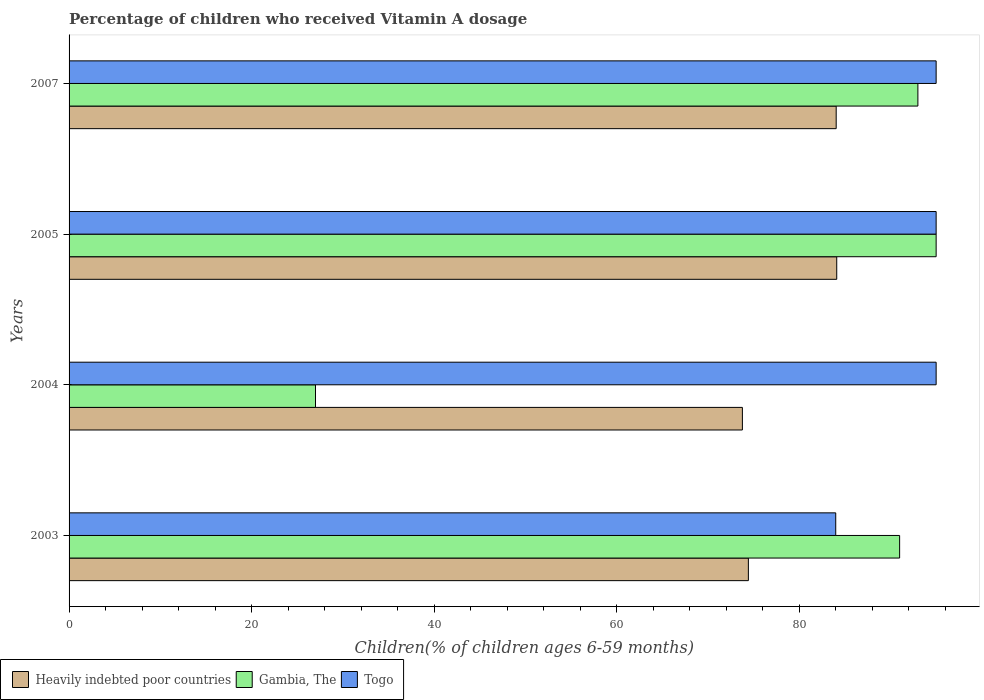Are the number of bars on each tick of the Y-axis equal?
Provide a short and direct response. Yes. How many bars are there on the 2nd tick from the top?
Offer a very short reply. 3. How many bars are there on the 2nd tick from the bottom?
Keep it short and to the point. 3. Across all years, what is the maximum percentage of children who received Vitamin A dosage in Heavily indebted poor countries?
Ensure brevity in your answer.  84.11. In which year was the percentage of children who received Vitamin A dosage in Togo minimum?
Provide a short and direct response. 2003. What is the total percentage of children who received Vitamin A dosage in Togo in the graph?
Provide a succinct answer. 369. What is the difference between the percentage of children who received Vitamin A dosage in Gambia, The in 2003 and that in 2007?
Provide a succinct answer. -2. What is the difference between the percentage of children who received Vitamin A dosage in Heavily indebted poor countries in 2004 and the percentage of children who received Vitamin A dosage in Togo in 2007?
Your answer should be very brief. -21.23. What is the average percentage of children who received Vitamin A dosage in Gambia, The per year?
Your response must be concise. 76.5. In the year 2004, what is the difference between the percentage of children who received Vitamin A dosage in Heavily indebted poor countries and percentage of children who received Vitamin A dosage in Togo?
Your answer should be very brief. -21.23. In how many years, is the percentage of children who received Vitamin A dosage in Gambia, The greater than 32 %?
Keep it short and to the point. 3. What is the ratio of the percentage of children who received Vitamin A dosage in Heavily indebted poor countries in 2003 to that in 2005?
Make the answer very short. 0.88. Is the percentage of children who received Vitamin A dosage in Heavily indebted poor countries in 2003 less than that in 2007?
Offer a very short reply. Yes. What is the difference between the highest and the second highest percentage of children who received Vitamin A dosage in Heavily indebted poor countries?
Make the answer very short. 0.06. In how many years, is the percentage of children who received Vitamin A dosage in Heavily indebted poor countries greater than the average percentage of children who received Vitamin A dosage in Heavily indebted poor countries taken over all years?
Make the answer very short. 2. What does the 2nd bar from the top in 2003 represents?
Your answer should be very brief. Gambia, The. What does the 1st bar from the bottom in 2003 represents?
Your answer should be compact. Heavily indebted poor countries. Is it the case that in every year, the sum of the percentage of children who received Vitamin A dosage in Heavily indebted poor countries and percentage of children who received Vitamin A dosage in Togo is greater than the percentage of children who received Vitamin A dosage in Gambia, The?
Make the answer very short. Yes. Are all the bars in the graph horizontal?
Your answer should be compact. Yes. What is the difference between two consecutive major ticks on the X-axis?
Offer a terse response. 20. Are the values on the major ticks of X-axis written in scientific E-notation?
Make the answer very short. No. Where does the legend appear in the graph?
Give a very brief answer. Bottom left. How many legend labels are there?
Offer a very short reply. 3. How are the legend labels stacked?
Your answer should be compact. Horizontal. What is the title of the graph?
Ensure brevity in your answer.  Percentage of children who received Vitamin A dosage. Does "Cabo Verde" appear as one of the legend labels in the graph?
Provide a short and direct response. No. What is the label or title of the X-axis?
Offer a very short reply. Children(% of children ages 6-59 months). What is the Children(% of children ages 6-59 months) of Heavily indebted poor countries in 2003?
Your answer should be very brief. 74.43. What is the Children(% of children ages 6-59 months) in Gambia, The in 2003?
Keep it short and to the point. 91. What is the Children(% of children ages 6-59 months) in Togo in 2003?
Your answer should be very brief. 84. What is the Children(% of children ages 6-59 months) in Heavily indebted poor countries in 2004?
Keep it short and to the point. 73.77. What is the Children(% of children ages 6-59 months) in Heavily indebted poor countries in 2005?
Keep it short and to the point. 84.11. What is the Children(% of children ages 6-59 months) in Heavily indebted poor countries in 2007?
Give a very brief answer. 84.05. What is the Children(% of children ages 6-59 months) of Gambia, The in 2007?
Offer a terse response. 93. What is the Children(% of children ages 6-59 months) of Togo in 2007?
Provide a short and direct response. 95. Across all years, what is the maximum Children(% of children ages 6-59 months) in Heavily indebted poor countries?
Give a very brief answer. 84.11. Across all years, what is the maximum Children(% of children ages 6-59 months) of Gambia, The?
Ensure brevity in your answer.  95. Across all years, what is the maximum Children(% of children ages 6-59 months) in Togo?
Your response must be concise. 95. Across all years, what is the minimum Children(% of children ages 6-59 months) of Heavily indebted poor countries?
Make the answer very short. 73.77. Across all years, what is the minimum Children(% of children ages 6-59 months) of Gambia, The?
Your answer should be very brief. 27. What is the total Children(% of children ages 6-59 months) of Heavily indebted poor countries in the graph?
Ensure brevity in your answer.  316.36. What is the total Children(% of children ages 6-59 months) of Gambia, The in the graph?
Provide a succinct answer. 306. What is the total Children(% of children ages 6-59 months) of Togo in the graph?
Make the answer very short. 369. What is the difference between the Children(% of children ages 6-59 months) in Heavily indebted poor countries in 2003 and that in 2004?
Give a very brief answer. 0.66. What is the difference between the Children(% of children ages 6-59 months) of Togo in 2003 and that in 2004?
Your answer should be very brief. -11. What is the difference between the Children(% of children ages 6-59 months) of Heavily indebted poor countries in 2003 and that in 2005?
Keep it short and to the point. -9.68. What is the difference between the Children(% of children ages 6-59 months) in Togo in 2003 and that in 2005?
Your answer should be compact. -11. What is the difference between the Children(% of children ages 6-59 months) in Heavily indebted poor countries in 2003 and that in 2007?
Give a very brief answer. -9.62. What is the difference between the Children(% of children ages 6-59 months) in Heavily indebted poor countries in 2004 and that in 2005?
Your answer should be compact. -10.34. What is the difference between the Children(% of children ages 6-59 months) in Gambia, The in 2004 and that in 2005?
Provide a short and direct response. -68. What is the difference between the Children(% of children ages 6-59 months) of Heavily indebted poor countries in 2004 and that in 2007?
Provide a short and direct response. -10.28. What is the difference between the Children(% of children ages 6-59 months) in Gambia, The in 2004 and that in 2007?
Your answer should be very brief. -66. What is the difference between the Children(% of children ages 6-59 months) of Heavily indebted poor countries in 2005 and that in 2007?
Make the answer very short. 0.06. What is the difference between the Children(% of children ages 6-59 months) in Togo in 2005 and that in 2007?
Your answer should be compact. 0. What is the difference between the Children(% of children ages 6-59 months) in Heavily indebted poor countries in 2003 and the Children(% of children ages 6-59 months) in Gambia, The in 2004?
Provide a succinct answer. 47.43. What is the difference between the Children(% of children ages 6-59 months) in Heavily indebted poor countries in 2003 and the Children(% of children ages 6-59 months) in Togo in 2004?
Your response must be concise. -20.57. What is the difference between the Children(% of children ages 6-59 months) of Heavily indebted poor countries in 2003 and the Children(% of children ages 6-59 months) of Gambia, The in 2005?
Offer a very short reply. -20.57. What is the difference between the Children(% of children ages 6-59 months) in Heavily indebted poor countries in 2003 and the Children(% of children ages 6-59 months) in Togo in 2005?
Provide a succinct answer. -20.57. What is the difference between the Children(% of children ages 6-59 months) in Gambia, The in 2003 and the Children(% of children ages 6-59 months) in Togo in 2005?
Provide a short and direct response. -4. What is the difference between the Children(% of children ages 6-59 months) in Heavily indebted poor countries in 2003 and the Children(% of children ages 6-59 months) in Gambia, The in 2007?
Offer a very short reply. -18.57. What is the difference between the Children(% of children ages 6-59 months) of Heavily indebted poor countries in 2003 and the Children(% of children ages 6-59 months) of Togo in 2007?
Provide a short and direct response. -20.57. What is the difference between the Children(% of children ages 6-59 months) in Heavily indebted poor countries in 2004 and the Children(% of children ages 6-59 months) in Gambia, The in 2005?
Provide a succinct answer. -21.23. What is the difference between the Children(% of children ages 6-59 months) in Heavily indebted poor countries in 2004 and the Children(% of children ages 6-59 months) in Togo in 2005?
Offer a terse response. -21.23. What is the difference between the Children(% of children ages 6-59 months) of Gambia, The in 2004 and the Children(% of children ages 6-59 months) of Togo in 2005?
Offer a very short reply. -68. What is the difference between the Children(% of children ages 6-59 months) in Heavily indebted poor countries in 2004 and the Children(% of children ages 6-59 months) in Gambia, The in 2007?
Provide a short and direct response. -19.23. What is the difference between the Children(% of children ages 6-59 months) in Heavily indebted poor countries in 2004 and the Children(% of children ages 6-59 months) in Togo in 2007?
Provide a short and direct response. -21.23. What is the difference between the Children(% of children ages 6-59 months) of Gambia, The in 2004 and the Children(% of children ages 6-59 months) of Togo in 2007?
Provide a succinct answer. -68. What is the difference between the Children(% of children ages 6-59 months) of Heavily indebted poor countries in 2005 and the Children(% of children ages 6-59 months) of Gambia, The in 2007?
Your response must be concise. -8.89. What is the difference between the Children(% of children ages 6-59 months) in Heavily indebted poor countries in 2005 and the Children(% of children ages 6-59 months) in Togo in 2007?
Provide a short and direct response. -10.89. What is the difference between the Children(% of children ages 6-59 months) of Gambia, The in 2005 and the Children(% of children ages 6-59 months) of Togo in 2007?
Your response must be concise. 0. What is the average Children(% of children ages 6-59 months) of Heavily indebted poor countries per year?
Provide a short and direct response. 79.09. What is the average Children(% of children ages 6-59 months) in Gambia, The per year?
Give a very brief answer. 76.5. What is the average Children(% of children ages 6-59 months) of Togo per year?
Make the answer very short. 92.25. In the year 2003, what is the difference between the Children(% of children ages 6-59 months) in Heavily indebted poor countries and Children(% of children ages 6-59 months) in Gambia, The?
Make the answer very short. -16.57. In the year 2003, what is the difference between the Children(% of children ages 6-59 months) in Heavily indebted poor countries and Children(% of children ages 6-59 months) in Togo?
Your response must be concise. -9.57. In the year 2004, what is the difference between the Children(% of children ages 6-59 months) in Heavily indebted poor countries and Children(% of children ages 6-59 months) in Gambia, The?
Your answer should be very brief. 46.77. In the year 2004, what is the difference between the Children(% of children ages 6-59 months) of Heavily indebted poor countries and Children(% of children ages 6-59 months) of Togo?
Offer a terse response. -21.23. In the year 2004, what is the difference between the Children(% of children ages 6-59 months) in Gambia, The and Children(% of children ages 6-59 months) in Togo?
Your answer should be compact. -68. In the year 2005, what is the difference between the Children(% of children ages 6-59 months) in Heavily indebted poor countries and Children(% of children ages 6-59 months) in Gambia, The?
Keep it short and to the point. -10.89. In the year 2005, what is the difference between the Children(% of children ages 6-59 months) in Heavily indebted poor countries and Children(% of children ages 6-59 months) in Togo?
Offer a very short reply. -10.89. In the year 2007, what is the difference between the Children(% of children ages 6-59 months) of Heavily indebted poor countries and Children(% of children ages 6-59 months) of Gambia, The?
Your response must be concise. -8.95. In the year 2007, what is the difference between the Children(% of children ages 6-59 months) of Heavily indebted poor countries and Children(% of children ages 6-59 months) of Togo?
Your answer should be compact. -10.95. What is the ratio of the Children(% of children ages 6-59 months) in Heavily indebted poor countries in 2003 to that in 2004?
Provide a succinct answer. 1.01. What is the ratio of the Children(% of children ages 6-59 months) in Gambia, The in 2003 to that in 2004?
Keep it short and to the point. 3.37. What is the ratio of the Children(% of children ages 6-59 months) in Togo in 2003 to that in 2004?
Your answer should be compact. 0.88. What is the ratio of the Children(% of children ages 6-59 months) in Heavily indebted poor countries in 2003 to that in 2005?
Offer a terse response. 0.88. What is the ratio of the Children(% of children ages 6-59 months) of Gambia, The in 2003 to that in 2005?
Give a very brief answer. 0.96. What is the ratio of the Children(% of children ages 6-59 months) of Togo in 2003 to that in 2005?
Ensure brevity in your answer.  0.88. What is the ratio of the Children(% of children ages 6-59 months) in Heavily indebted poor countries in 2003 to that in 2007?
Ensure brevity in your answer.  0.89. What is the ratio of the Children(% of children ages 6-59 months) of Gambia, The in 2003 to that in 2007?
Your response must be concise. 0.98. What is the ratio of the Children(% of children ages 6-59 months) in Togo in 2003 to that in 2007?
Provide a succinct answer. 0.88. What is the ratio of the Children(% of children ages 6-59 months) in Heavily indebted poor countries in 2004 to that in 2005?
Your response must be concise. 0.88. What is the ratio of the Children(% of children ages 6-59 months) of Gambia, The in 2004 to that in 2005?
Your answer should be very brief. 0.28. What is the ratio of the Children(% of children ages 6-59 months) of Heavily indebted poor countries in 2004 to that in 2007?
Give a very brief answer. 0.88. What is the ratio of the Children(% of children ages 6-59 months) of Gambia, The in 2004 to that in 2007?
Ensure brevity in your answer.  0.29. What is the ratio of the Children(% of children ages 6-59 months) in Togo in 2004 to that in 2007?
Make the answer very short. 1. What is the ratio of the Children(% of children ages 6-59 months) in Heavily indebted poor countries in 2005 to that in 2007?
Keep it short and to the point. 1. What is the ratio of the Children(% of children ages 6-59 months) of Gambia, The in 2005 to that in 2007?
Your response must be concise. 1.02. What is the difference between the highest and the second highest Children(% of children ages 6-59 months) of Heavily indebted poor countries?
Give a very brief answer. 0.06. What is the difference between the highest and the second highest Children(% of children ages 6-59 months) of Gambia, The?
Offer a very short reply. 2. What is the difference between the highest and the lowest Children(% of children ages 6-59 months) in Heavily indebted poor countries?
Make the answer very short. 10.34. What is the difference between the highest and the lowest Children(% of children ages 6-59 months) in Gambia, The?
Provide a short and direct response. 68. What is the difference between the highest and the lowest Children(% of children ages 6-59 months) in Togo?
Offer a very short reply. 11. 